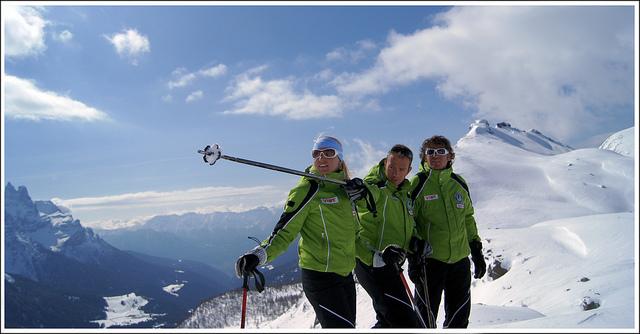What color are the jackets?
Quick response, please. Green. How many people are wearing hats?
Short answer required. 1. What color are the lady's jackets?
Short answer required. Green. 